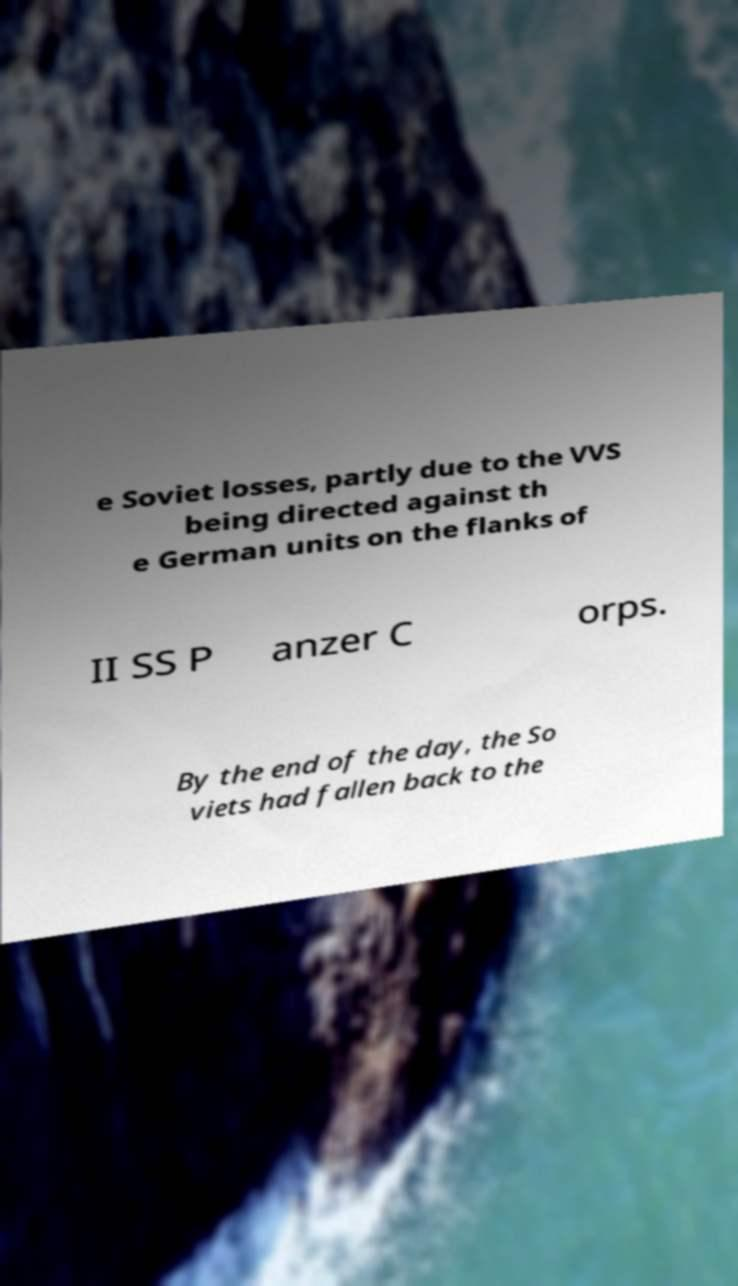There's text embedded in this image that I need extracted. Can you transcribe it verbatim? e Soviet losses, partly due to the VVS being directed against th e German units on the flanks of II SS P anzer C orps. By the end of the day, the So viets had fallen back to the 